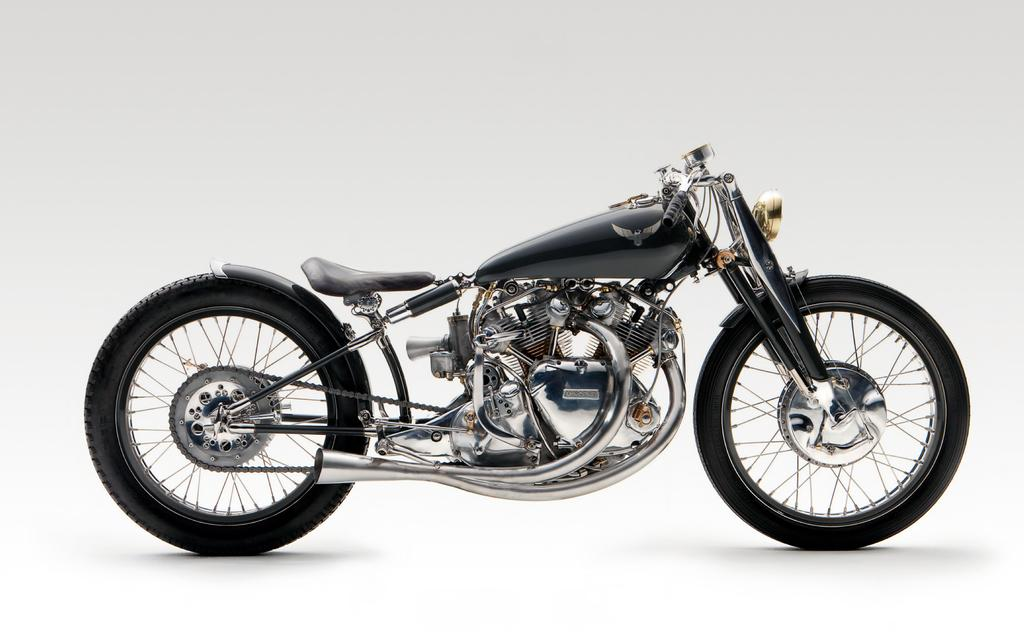What type of vehicle is in the image? There is a motorbike in the image. How many seats does the motorbike have? The motorbike has only one seat. What type of appliance is being discussed in the image? There is no appliance being discussed in the image; it features a motorbike with one seat. How many books are visible on the motorbike in the image? There are no books visible on the motorbike in the image. 